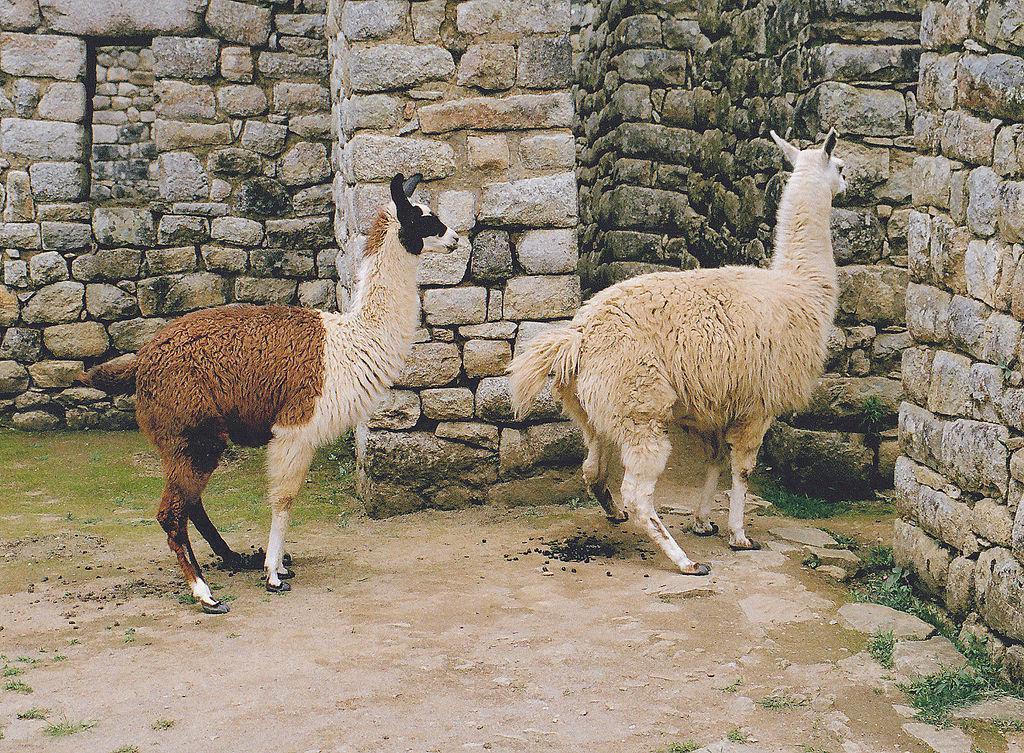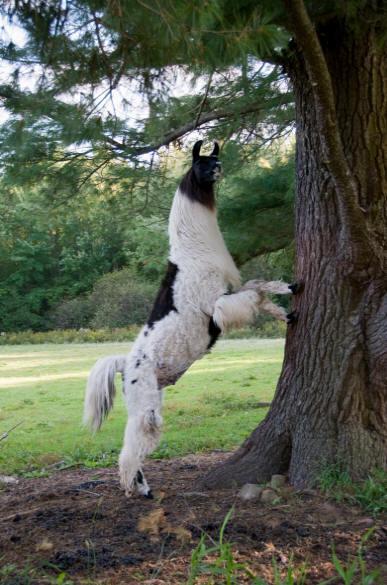The first image is the image on the left, the second image is the image on the right. For the images shown, is this caption "One llama is not standing on four legs." true? Answer yes or no. Yes. The first image is the image on the left, the second image is the image on the right. Examine the images to the left and right. Is the description "In one image, two llamas - including a brown-and-white one - are next to a rustic stone wall." accurate? Answer yes or no. Yes. 